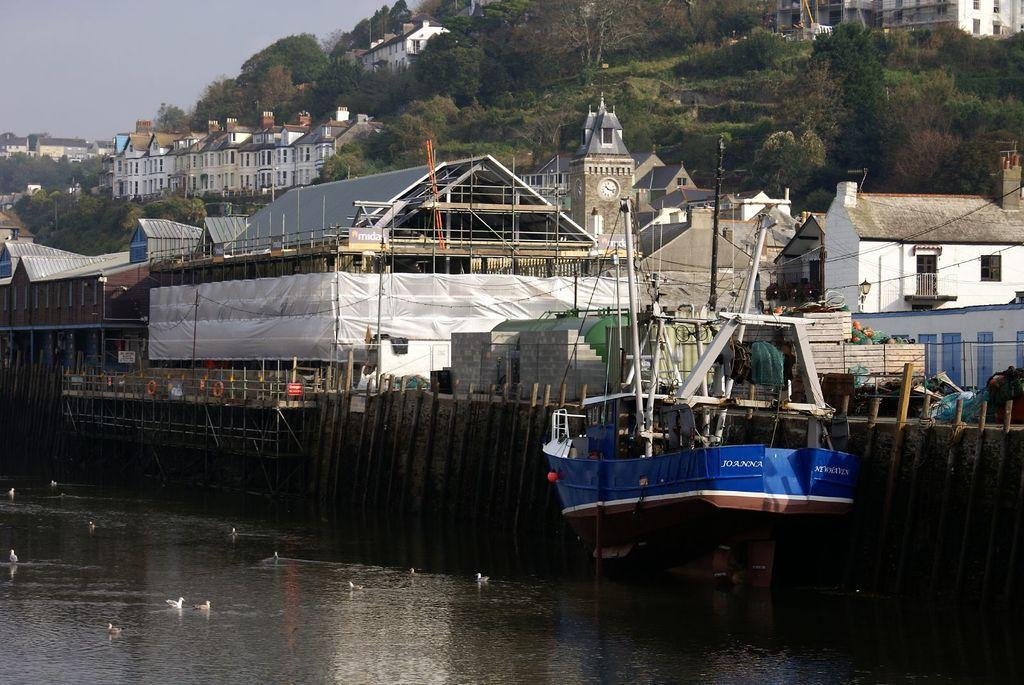How would you summarize this image in a sentence or two? At the bottom of the image there is water. There is a ship on the water and also there are birds in the water. Behind the ship there is a wall and also there are wooden poles. Behind them there are buildings with walls, windows, roofs and chimneys. There is a building tower with a clock. And there is a construction of a building. In the background there are trees. 